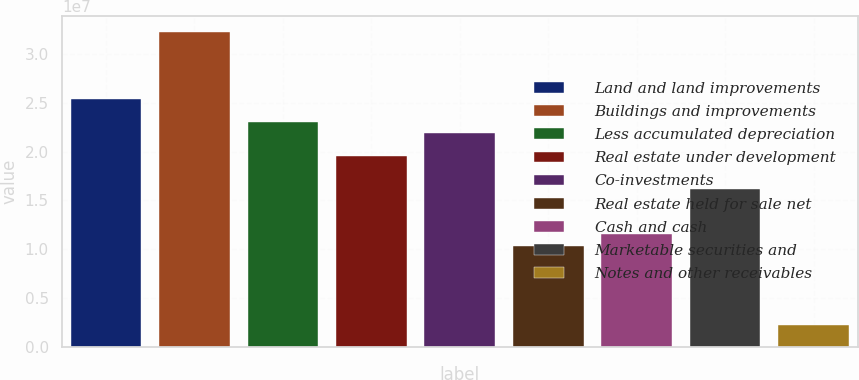<chart> <loc_0><loc_0><loc_500><loc_500><bar_chart><fcel>Land and land improvements<fcel>Buildings and improvements<fcel>Less accumulated depreciation<fcel>Real estate under development<fcel>Co-investments<fcel>Real estate held for sale net<fcel>Cash and cash<fcel>Marketable securities and<fcel>Notes and other receivables<nl><fcel>2.53588e+07<fcel>3.22748e+07<fcel>2.30535e+07<fcel>1.95954e+07<fcel>2.19008e+07<fcel>1.03741e+07<fcel>1.15267e+07<fcel>1.61374e+07<fcel>2.30535e+06<nl></chart> 